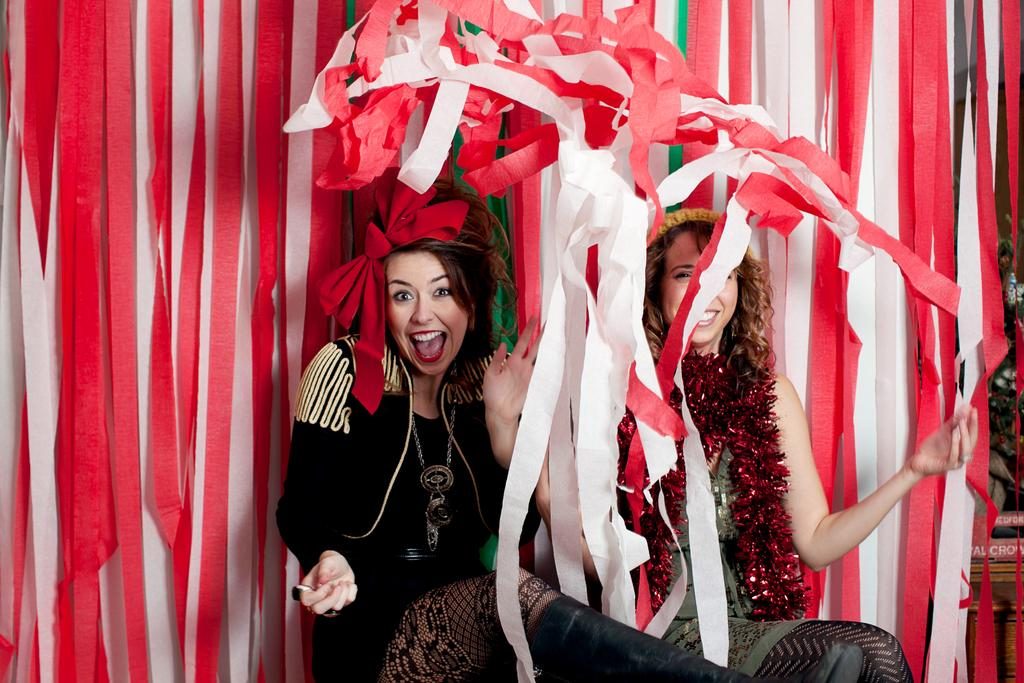How many women are in the picture? There are two women in the picture. What are the women doing in the image? The women are sitting and laughing. What are the women wearing? The women are wearing different costumes. What can be seen in the background of the image? There is a wall visible in the background, and it is decorated with red and white ribbons. What type of dirt can be seen on the writer's hands in the image? There is no writer or dirt present in the image. What is the rake being used for in the image? There is no rake present in the image. 